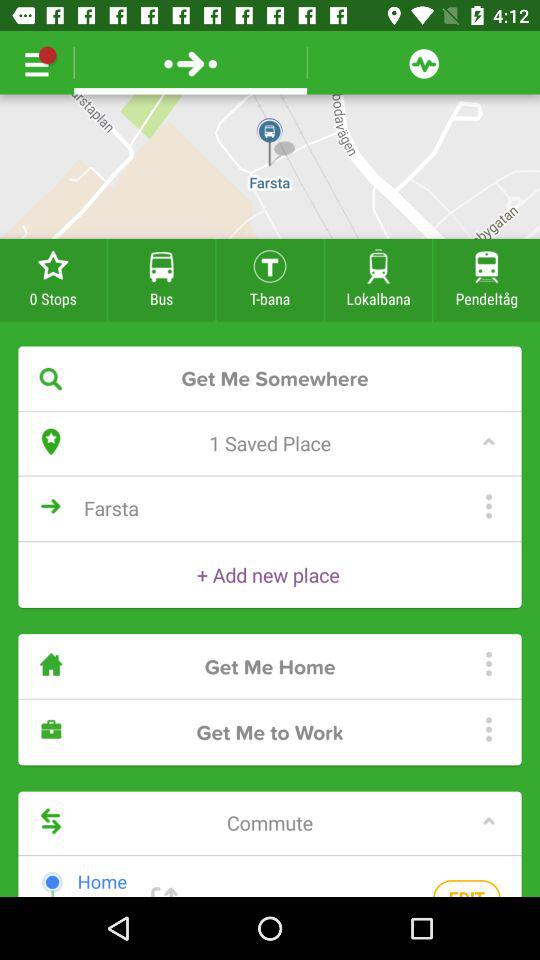How much does the trip cost?
When the provided information is insufficient, respond with <no answer>. <no answer> 